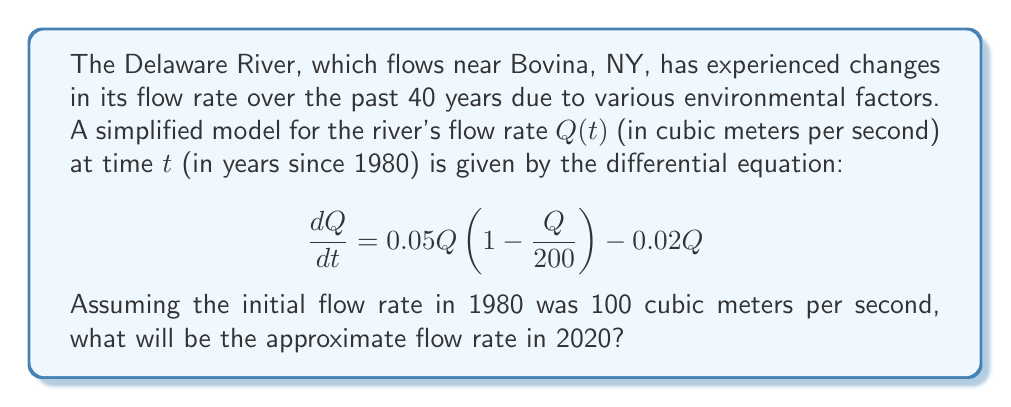Teach me how to tackle this problem. To solve this problem, we need to use the given differential equation and initial condition to model the river's flow rate over time. Let's approach this step-by-step:

1) The given differential equation is:

   $$\frac{dQ}{dt} = 0.05Q(1 - \frac{Q}{200}) - 0.02Q$$

2) This is a logistic growth model with an additional decay term. We can rearrange it:

   $$\frac{dQ}{dt} = 0.05Q - \frac{0.05Q^2}{200} - 0.02Q = 0.03Q - \frac{0.00025Q^2}{1}$$

3) This equation doesn't have a simple analytical solution, so we'll use a numerical method. Let's use the Euler method with a step size of 1 year.

4) The Euler method is given by:

   $$Q_{n+1} = Q_n + h \cdot f(Q_n)$$

   where $h$ is the step size (1 year in our case) and $f(Q) = 0.03Q - 0.00025Q^2$

5) Starting with $Q_0 = 100$, we can iterate:

   $Q_1 = 100 + 1 \cdot (0.03 \cdot 100 - 0.00025 \cdot 100^2) = 102.5$
   $Q_2 = 102.5 + 1 \cdot (0.03 \cdot 102.5 - 0.00025 \cdot 102.5^2) = 104.84375$
   ...

6) Continuing this process for 40 steps (from 1980 to 2020), we get:

   $Q_{40} \approx 117.65$

Therefore, the approximate flow rate in 2020 will be about 117.65 cubic meters per second.
Answer: The approximate flow rate of the Delaware River near Bovina, NY in 2020 will be 117.65 cubic meters per second. 